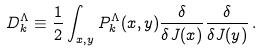<formula> <loc_0><loc_0><loc_500><loc_500>D _ { k } ^ { \Lambda } \equiv \frac { 1 } { 2 } \int _ { x , y } P _ { k } ^ { \Lambda } ( x , y ) \frac { \delta } { \delta J ( x ) } \frac { \delta } { \delta J ( y ) } \, .</formula> 